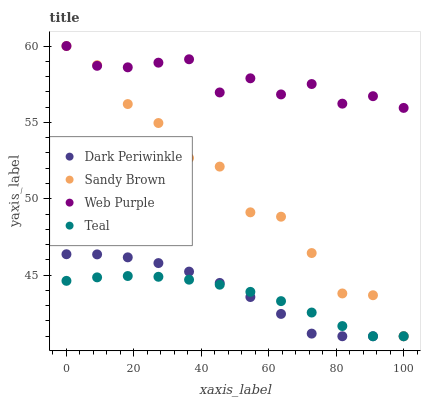Does Teal have the minimum area under the curve?
Answer yes or no. Yes. Does Web Purple have the maximum area under the curve?
Answer yes or no. Yes. Does Sandy Brown have the minimum area under the curve?
Answer yes or no. No. Does Sandy Brown have the maximum area under the curve?
Answer yes or no. No. Is Teal the smoothest?
Answer yes or no. Yes. Is Sandy Brown the roughest?
Answer yes or no. Yes. Is Dark Periwinkle the smoothest?
Answer yes or no. No. Is Dark Periwinkle the roughest?
Answer yes or no. No. Does Sandy Brown have the lowest value?
Answer yes or no. Yes. Does Sandy Brown have the highest value?
Answer yes or no. Yes. Does Dark Periwinkle have the highest value?
Answer yes or no. No. Is Teal less than Web Purple?
Answer yes or no. Yes. Is Web Purple greater than Teal?
Answer yes or no. Yes. Does Web Purple intersect Sandy Brown?
Answer yes or no. Yes. Is Web Purple less than Sandy Brown?
Answer yes or no. No. Is Web Purple greater than Sandy Brown?
Answer yes or no. No. Does Teal intersect Web Purple?
Answer yes or no. No. 